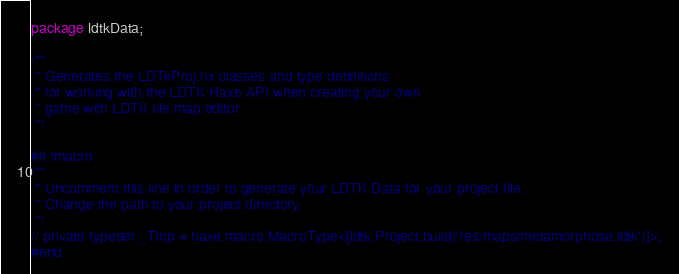<code> <loc_0><loc_0><loc_500><loc_500><_Haxe_>package ldtkData;

/**
 * Generates the LDTkProj.hx classes and type definitions
 * for working with the LDTK Haxe API when creating your own
 * game with LDTK tile map editor.
 */

#if !macro
/**
 * Uncomment this line in order to generate your LDTK Data for your project file.
 * Change the path to your project directory.
 */
// private typedef _Tmp = haxe.macro.MacroType<[ldtk.Project.build('res/maps/metamorphose.ldtk')]>;
#end</code> 